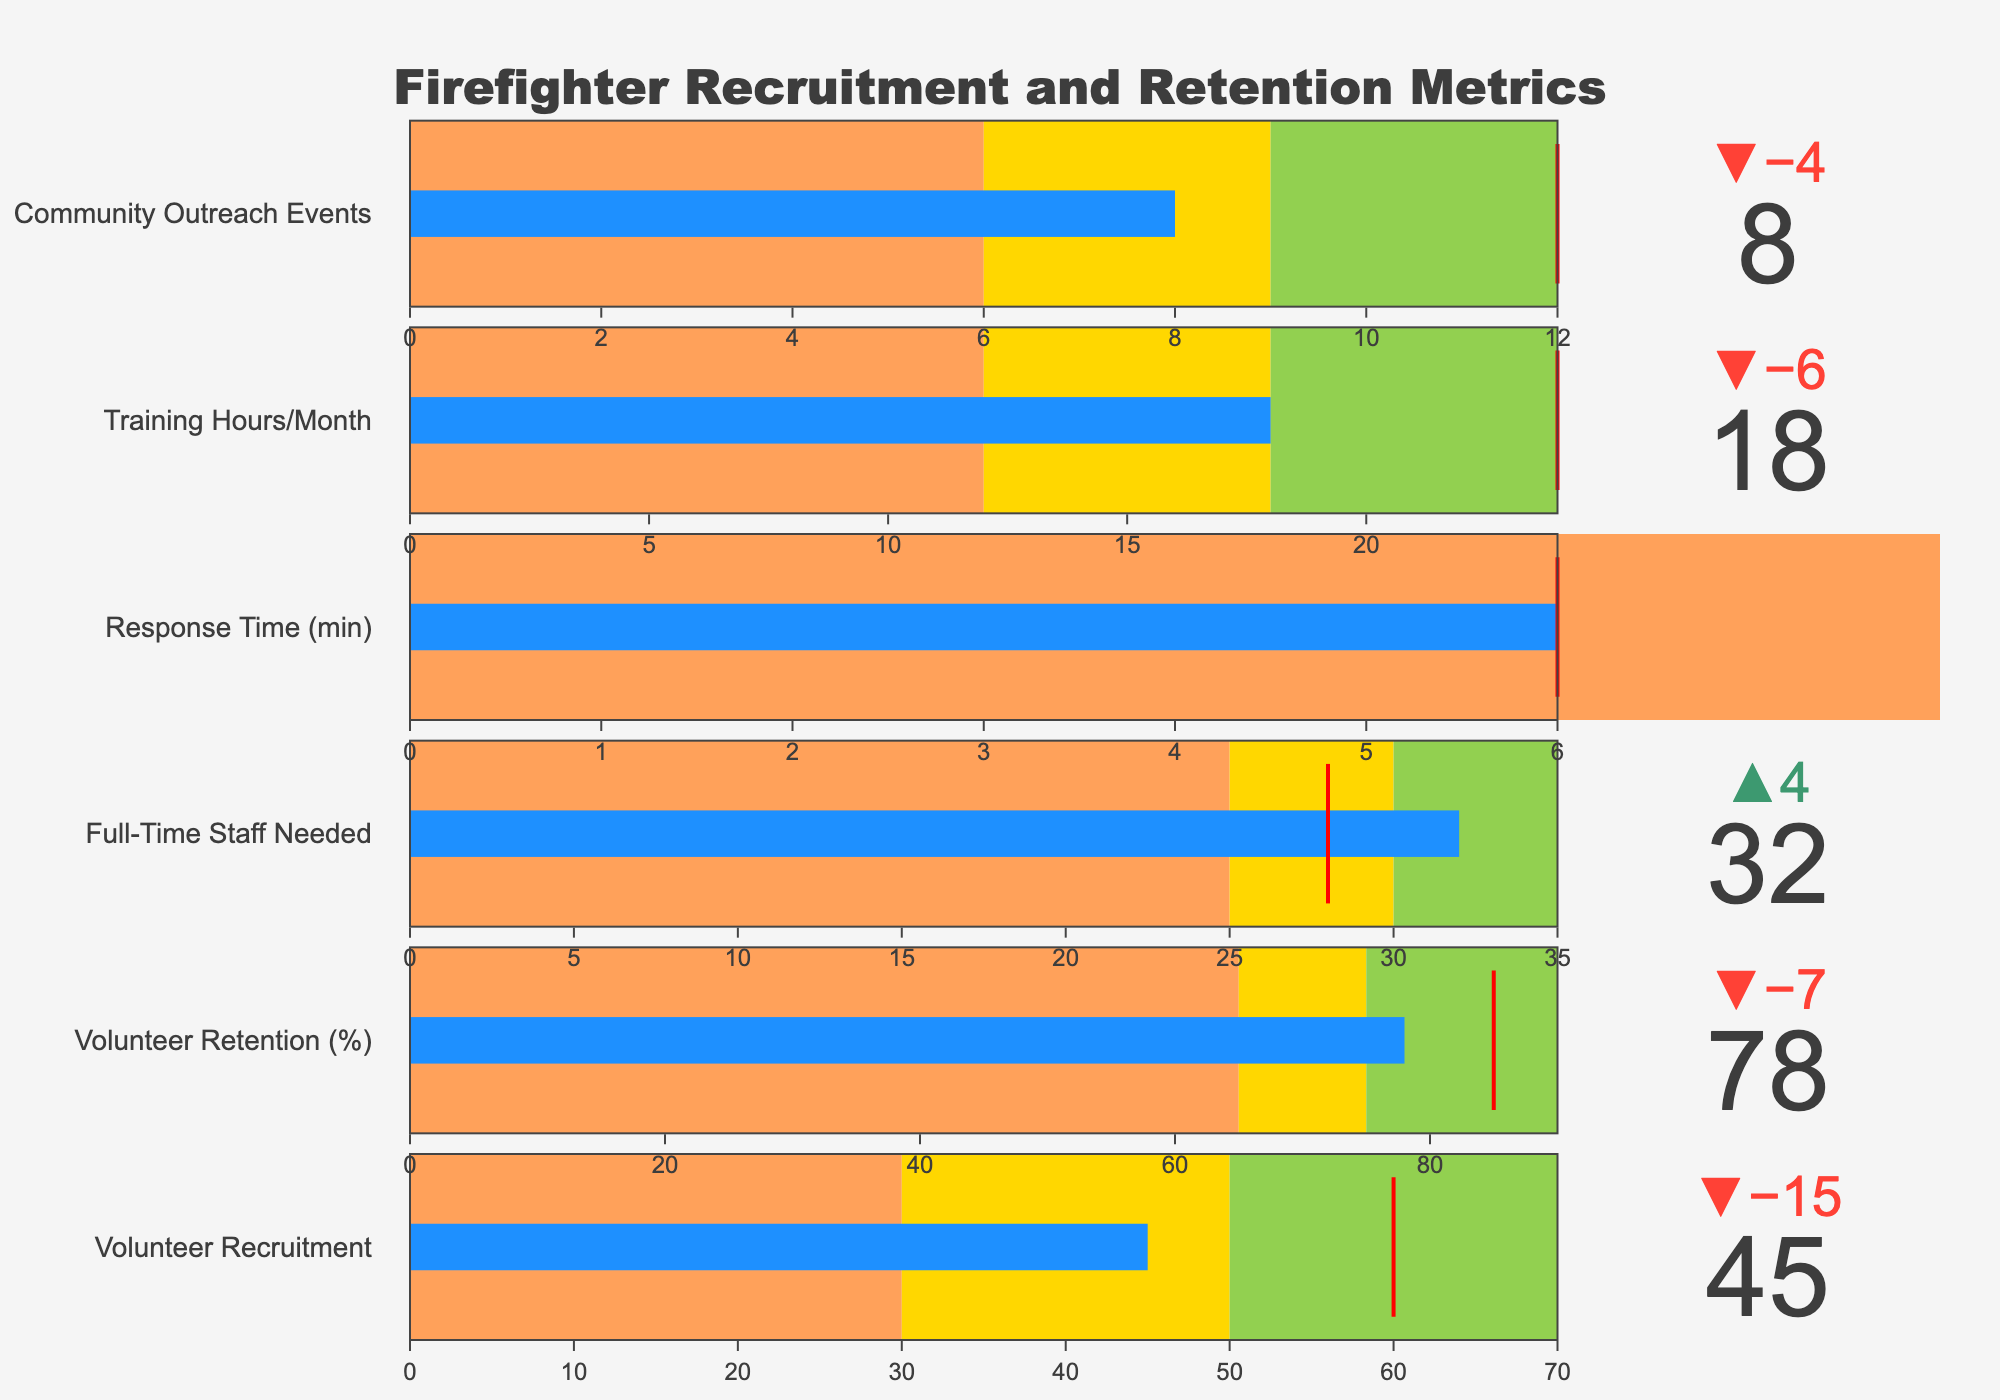What is the title of the figure? The title is displayed at the top of the figure. It is clearly written in larger font and centered.
Answer: Firefighter Recruitment and Retention Metrics In which category is the actual value higher than the target value? The full-time staff needed category shows an actual value of 32, which is higher than the target of 28.
Answer: Full-Time Staff Needed What is the actual retention percentage for volunteers? The actual retention percentage for volunteers is shown as a numeric value directly on the chart.
Answer: 78% How many hours of training per month are actually being provided compared to the target? The actual training hours per month are shown as 18, while the target is 24 hours. The chart displays these values side by side for comparison.
Answer: 18 hours vs 24 hours What recruitment rate is required to reach the target in the Volunteer Recruitment category? The target recruitment rate for volunteers is shown as 60. The actual value is 45. The required increase is calculated by subtracting the actual from the target, 60 - 45 = 15.
Answer: 15 more recruits needed What is the delta between the actual and target response time? The target response time is 6 minutes, and the actual response time is 7.2 minutes. The delta is calculated with 7.2 - 6 = 1.2 minutes.
Answer: 1.2 minutes Which metric has the closest actual value to its target? The comparison of actual values to target values shows that the category with the smallest difference needs to be identified. Volunteer retention has actual 78% and target 85%, resulting in a difference of 7%.
Answer: Volunteer Recruitment How many community outreach events are being held compared to the target? The actual number of community outreach events is 8, displayed against the target of 12 in the figure.
Answer: 8 events Which category has an actual value that is within the green range (Range3)? The categories showing green range (above the second range limit) with their actual value clearly above this limit must be checked. The Full-Time Staff Needed category (actual value 32) falls within the green range (25-35).
Answer: Full-Time Staff Needed Among the categories evaluated, which one shows an area of concern based on the color coding? The colors represent concern levels in bullet charts, with orange typically indicating a shortfall. Training Hours/Month in this chart falls within the orange range (actual 18; range1 ends at 12).
Answer: Training Hours/Month 